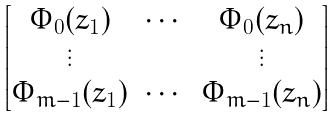Convert formula to latex. <formula><loc_0><loc_0><loc_500><loc_500>\begin{bmatrix} \Phi _ { 0 } ( z _ { 1 } ) & \cdots & \Phi _ { 0 } ( z _ { n } ) \\ \vdots & & \vdots \\ \Phi _ { m - 1 } ( z _ { 1 } ) & \cdots & \Phi _ { m - 1 } ( z _ { n } ) \end{bmatrix}</formula> 